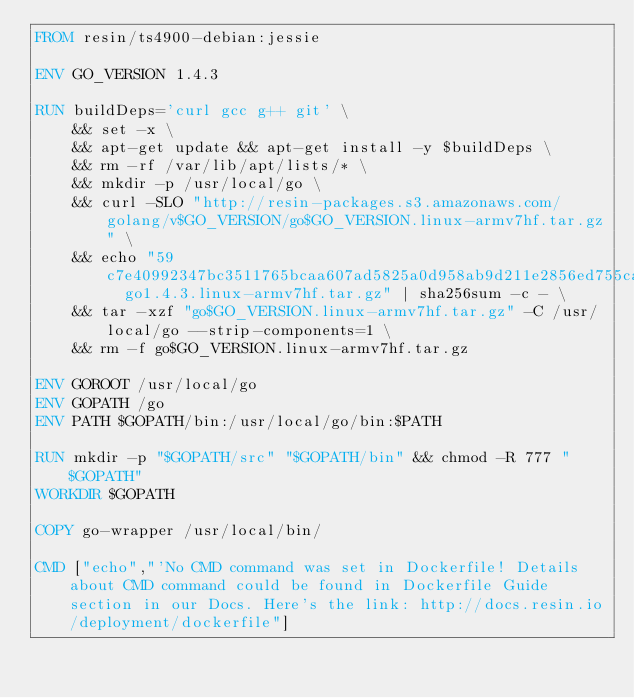<code> <loc_0><loc_0><loc_500><loc_500><_Dockerfile_>FROM resin/ts4900-debian:jessie

ENV GO_VERSION 1.4.3

RUN buildDeps='curl gcc g++ git' \
	&& set -x \
	&& apt-get update && apt-get install -y $buildDeps \
	&& rm -rf /var/lib/apt/lists/* \
	&& mkdir -p /usr/local/go \
	&& curl -SLO "http://resin-packages.s3.amazonaws.com/golang/v$GO_VERSION/go$GO_VERSION.linux-armv7hf.tar.gz" \
	&& echo "59c7e40992347bc3511765bcaa607ad5825a0d958ab9d211e2856ed755ca5a09  go1.4.3.linux-armv7hf.tar.gz" | sha256sum -c - \
	&& tar -xzf "go$GO_VERSION.linux-armv7hf.tar.gz" -C /usr/local/go --strip-components=1 \
	&& rm -f go$GO_VERSION.linux-armv7hf.tar.gz

ENV GOROOT /usr/local/go
ENV GOPATH /go
ENV PATH $GOPATH/bin:/usr/local/go/bin:$PATH

RUN mkdir -p "$GOPATH/src" "$GOPATH/bin" && chmod -R 777 "$GOPATH"
WORKDIR $GOPATH

COPY go-wrapper /usr/local/bin/

CMD ["echo","'No CMD command was set in Dockerfile! Details about CMD command could be found in Dockerfile Guide section in our Docs. Here's the link: http://docs.resin.io/deployment/dockerfile"]
</code> 